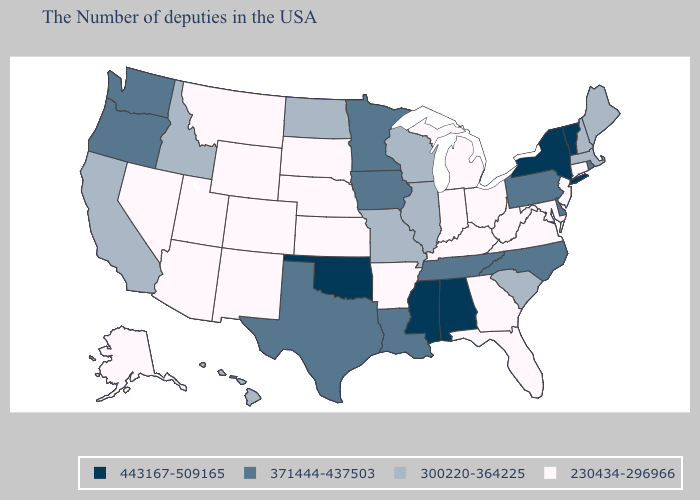Name the states that have a value in the range 371444-437503?
Concise answer only. Rhode Island, Delaware, Pennsylvania, North Carolina, Tennessee, Louisiana, Minnesota, Iowa, Texas, Washington, Oregon. Among the states that border Alabama , does Georgia have the highest value?
Give a very brief answer. No. Name the states that have a value in the range 300220-364225?
Answer briefly. Maine, Massachusetts, New Hampshire, South Carolina, Wisconsin, Illinois, Missouri, North Dakota, Idaho, California, Hawaii. What is the highest value in the USA?
Short answer required. 443167-509165. What is the value of Georgia?
Concise answer only. 230434-296966. What is the highest value in the USA?
Write a very short answer. 443167-509165. What is the highest value in states that border Idaho?
Write a very short answer. 371444-437503. Which states have the lowest value in the USA?
Answer briefly. Connecticut, New Jersey, Maryland, Virginia, West Virginia, Ohio, Florida, Georgia, Michigan, Kentucky, Indiana, Arkansas, Kansas, Nebraska, South Dakota, Wyoming, Colorado, New Mexico, Utah, Montana, Arizona, Nevada, Alaska. Does the first symbol in the legend represent the smallest category?
Short answer required. No. What is the value of Pennsylvania?
Concise answer only. 371444-437503. What is the value of Pennsylvania?
Concise answer only. 371444-437503. What is the highest value in the Northeast ?
Keep it brief. 443167-509165. What is the value of Rhode Island?
Give a very brief answer. 371444-437503. Which states have the highest value in the USA?
Concise answer only. Vermont, New York, Alabama, Mississippi, Oklahoma. Name the states that have a value in the range 300220-364225?
Give a very brief answer. Maine, Massachusetts, New Hampshire, South Carolina, Wisconsin, Illinois, Missouri, North Dakota, Idaho, California, Hawaii. 